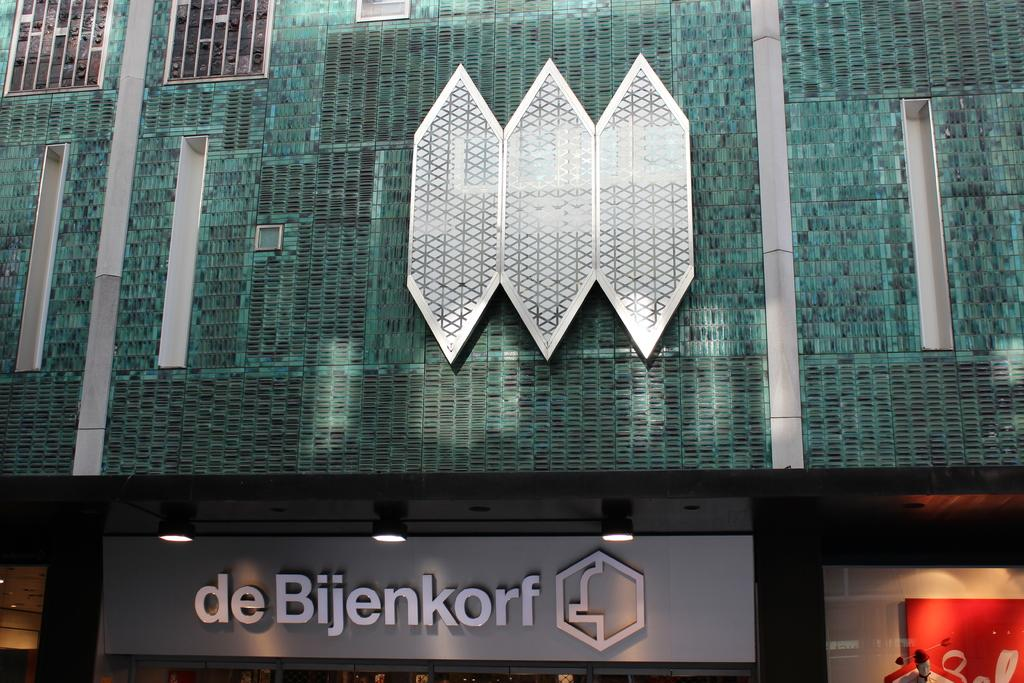What type of structure is visible in the image? There is a building in the image. What objects are present near the building? There are boards and a mannequin visible in the image. What can be seen illuminating the scene in the image? There are lights in the image. How many brothers are standing next to the mannequin in the image? There is no mention of brothers in the image, and only a mannequin is present. 